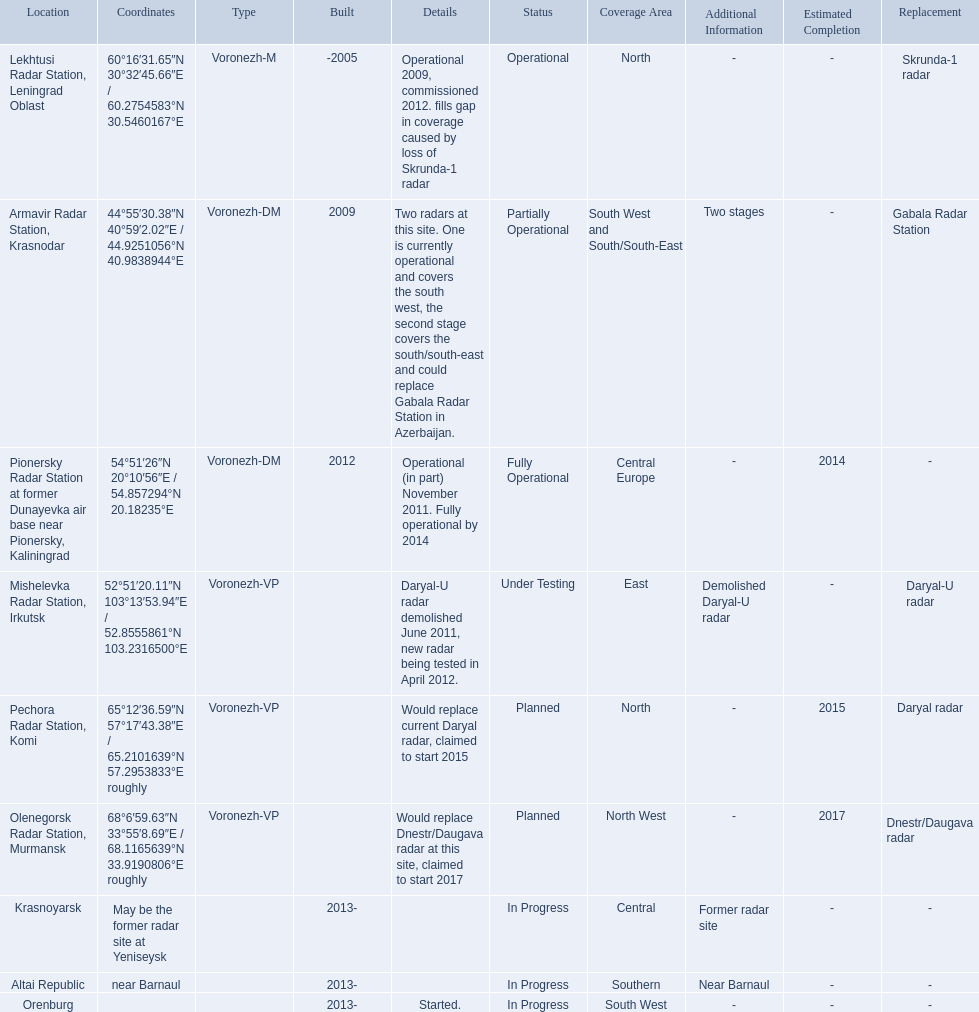Voronezh radar has locations where? Lekhtusi Radar Station, Leningrad Oblast, Armavir Radar Station, Krasnodar, Pionersky Radar Station at former Dunayevka air base near Pionersky, Kaliningrad, Mishelevka Radar Station, Irkutsk, Pechora Radar Station, Komi, Olenegorsk Radar Station, Murmansk, Krasnoyarsk, Altai Republic, Orenburg. Which of these locations have know coordinates? Lekhtusi Radar Station, Leningrad Oblast, Armavir Radar Station, Krasnodar, Pionersky Radar Station at former Dunayevka air base near Pionersky, Kaliningrad, Mishelevka Radar Station, Irkutsk, Pechora Radar Station, Komi, Olenegorsk Radar Station, Murmansk. Which of these locations has coordinates of 60deg16'31.65''n 30deg32'45.66''e / 60.2754583degn 30.5460167dege? Lekhtusi Radar Station, Leningrad Oblast. 